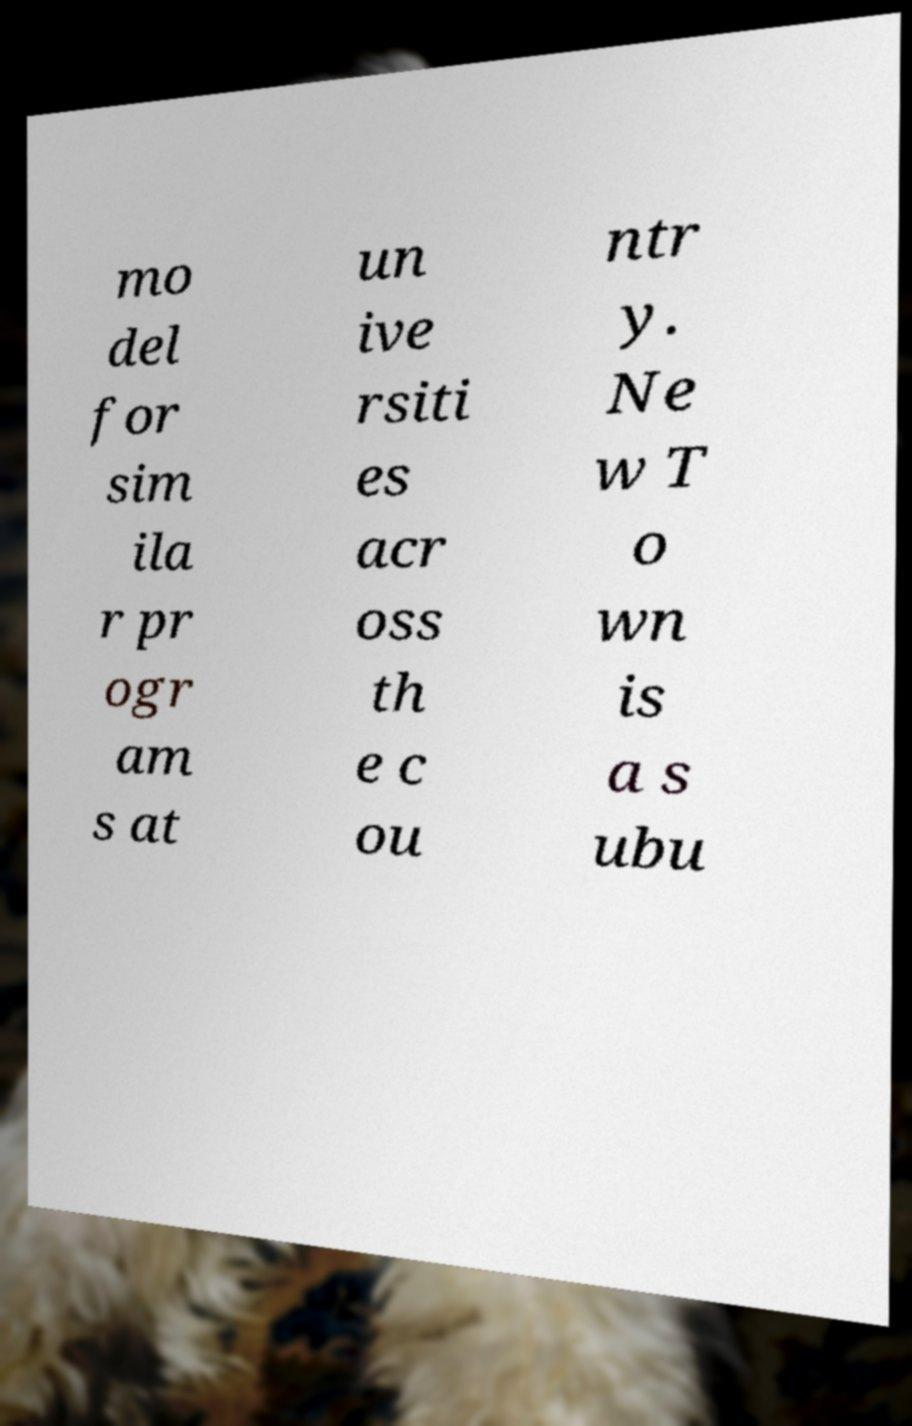What messages or text are displayed in this image? I need them in a readable, typed format. mo del for sim ila r pr ogr am s at un ive rsiti es acr oss th e c ou ntr y. Ne w T o wn is a s ubu 